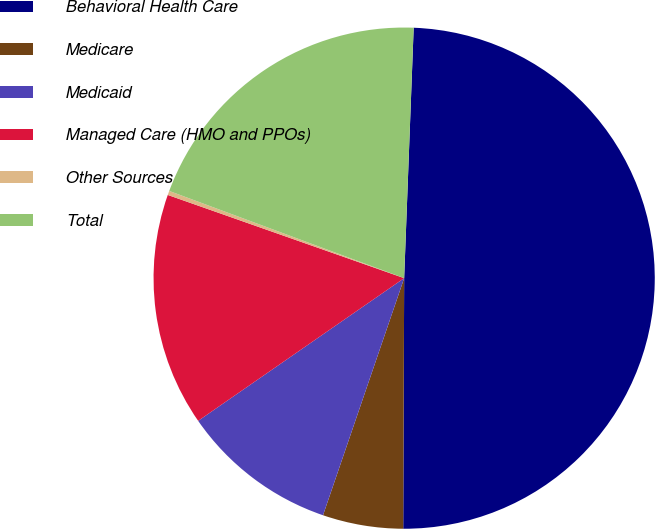Convert chart to OTSL. <chart><loc_0><loc_0><loc_500><loc_500><pie_chart><fcel>Behavioral Health Care<fcel>Medicare<fcel>Medicaid<fcel>Managed Care (HMO and PPOs)<fcel>Other Sources<fcel>Total<nl><fcel>49.46%<fcel>5.19%<fcel>10.11%<fcel>15.03%<fcel>0.27%<fcel>19.95%<nl></chart> 